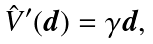<formula> <loc_0><loc_0><loc_500><loc_500>\hat { V } ^ { \prime } ( \boldsymbol d ) = \gamma \boldsymbol d ,</formula> 